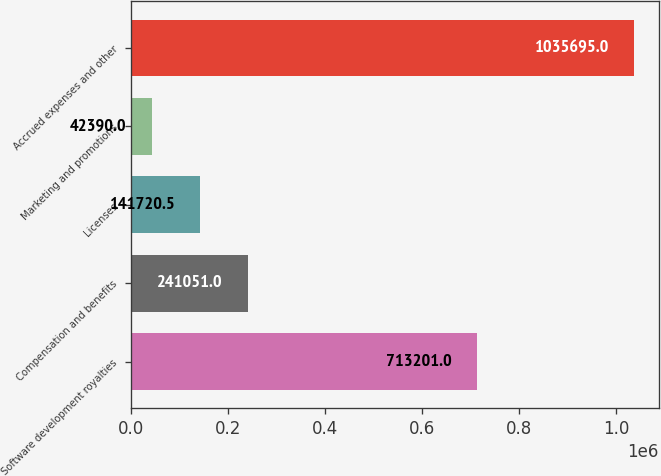Convert chart. <chart><loc_0><loc_0><loc_500><loc_500><bar_chart><fcel>Software development royalties<fcel>Compensation and benefits<fcel>Licenses<fcel>Marketing and promotions<fcel>Accrued expenses and other<nl><fcel>713201<fcel>241051<fcel>141720<fcel>42390<fcel>1.0357e+06<nl></chart> 